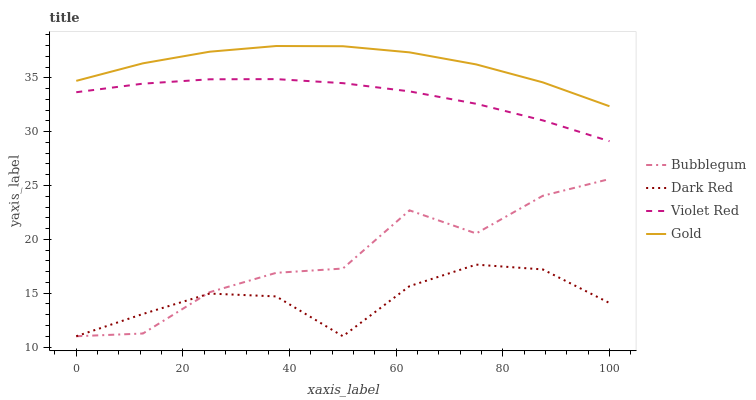Does Dark Red have the minimum area under the curve?
Answer yes or no. Yes. Does Gold have the maximum area under the curve?
Answer yes or no. Yes. Does Violet Red have the minimum area under the curve?
Answer yes or no. No. Does Violet Red have the maximum area under the curve?
Answer yes or no. No. Is Violet Red the smoothest?
Answer yes or no. Yes. Is Bubblegum the roughest?
Answer yes or no. Yes. Is Gold the smoothest?
Answer yes or no. No. Is Gold the roughest?
Answer yes or no. No. Does Dark Red have the lowest value?
Answer yes or no. Yes. Does Violet Red have the lowest value?
Answer yes or no. No. Does Gold have the highest value?
Answer yes or no. Yes. Does Violet Red have the highest value?
Answer yes or no. No. Is Violet Red less than Gold?
Answer yes or no. Yes. Is Gold greater than Dark Red?
Answer yes or no. Yes. Does Bubblegum intersect Dark Red?
Answer yes or no. Yes. Is Bubblegum less than Dark Red?
Answer yes or no. No. Is Bubblegum greater than Dark Red?
Answer yes or no. No. Does Violet Red intersect Gold?
Answer yes or no. No. 